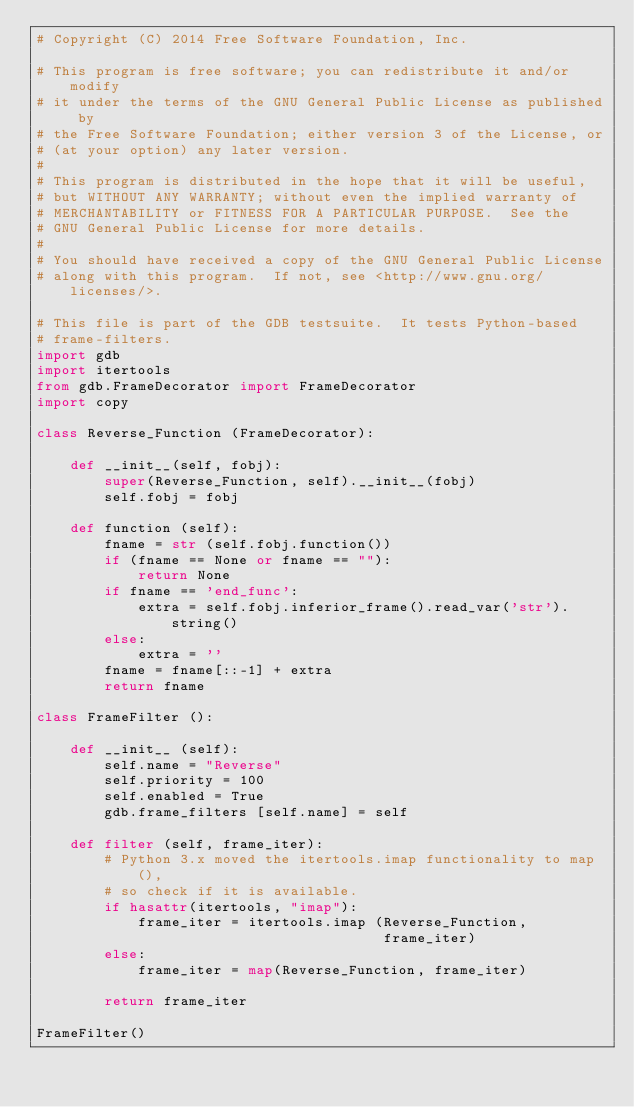<code> <loc_0><loc_0><loc_500><loc_500><_Python_># Copyright (C) 2014 Free Software Foundation, Inc.

# This program is free software; you can redistribute it and/or modify
# it under the terms of the GNU General Public License as published by
# the Free Software Foundation; either version 3 of the License, or
# (at your option) any later version.
#
# This program is distributed in the hope that it will be useful,
# but WITHOUT ANY WARRANTY; without even the implied warranty of
# MERCHANTABILITY or FITNESS FOR A PARTICULAR PURPOSE.  See the
# GNU General Public License for more details.
#
# You should have received a copy of the GNU General Public License
# along with this program.  If not, see <http://www.gnu.org/licenses/>.

# This file is part of the GDB testsuite.  It tests Python-based
# frame-filters.
import gdb
import itertools
from gdb.FrameDecorator import FrameDecorator
import copy

class Reverse_Function (FrameDecorator):

    def __init__(self, fobj):
        super(Reverse_Function, self).__init__(fobj)
        self.fobj = fobj

    def function (self):
        fname = str (self.fobj.function())
        if (fname == None or fname == ""):
            return None
        if fname == 'end_func':
            extra = self.fobj.inferior_frame().read_var('str').string()
        else:
            extra = ''
        fname = fname[::-1] + extra
        return fname

class FrameFilter ():

    def __init__ (self):
        self.name = "Reverse"
        self.priority = 100
        self.enabled = True
        gdb.frame_filters [self.name] = self

    def filter (self, frame_iter):
        # Python 3.x moved the itertools.imap functionality to map(),
        # so check if it is available.
        if hasattr(itertools, "imap"):
            frame_iter = itertools.imap (Reverse_Function,
                                         frame_iter)
        else:
            frame_iter = map(Reverse_Function, frame_iter)

        return frame_iter

FrameFilter()
</code> 